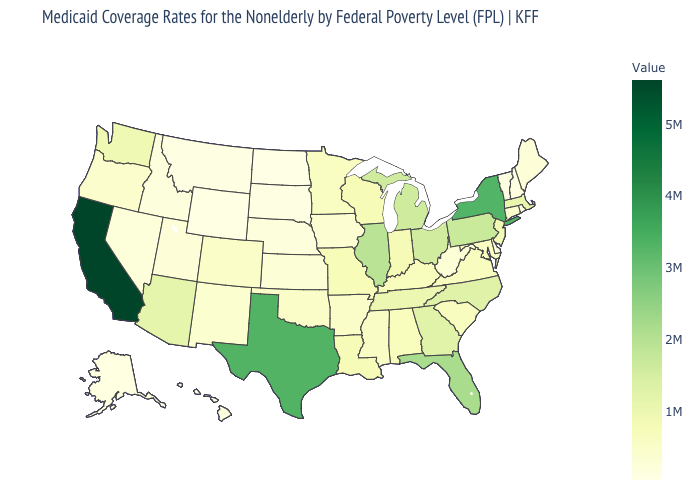Which states have the lowest value in the USA?
Concise answer only. North Dakota. Does North Dakota have the lowest value in the USA?
Give a very brief answer. Yes. Among the states that border Vermont , does New York have the highest value?
Give a very brief answer. Yes. Does the map have missing data?
Be succinct. No. Among the states that border Rhode Island , does Massachusetts have the lowest value?
Answer briefly. No. Among the states that border Vermont , does New York have the lowest value?
Quick response, please. No. 